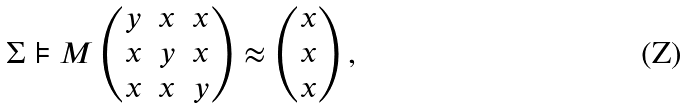Convert formula to latex. <formula><loc_0><loc_0><loc_500><loc_500>\Sigma \models { M } \left ( \begin{matrix} y & x & x \\ x & y & x \\ x & x & y \end{matrix} \right ) \approx \left ( \begin{matrix} x \\ x \\ x \end{matrix} \right ) ,</formula> 